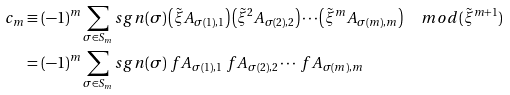Convert formula to latex. <formula><loc_0><loc_0><loc_500><loc_500>c _ { m } & \equiv ( - 1 ) ^ { m } \sum _ { \sigma \in S _ { m } } s g n ( \sigma ) \left ( \tilde { \xi } A _ { \sigma ( 1 ) , 1 } \right ) \left ( \tilde { \xi } ^ { 2 } A _ { \sigma ( 2 ) , 2 } \right ) \cdots \left ( \tilde { \xi } ^ { m } A _ { \sigma ( m ) , m } \right ) \quad m o d ( \tilde { \xi } ^ { m + 1 } ) \\ & = ( - 1 ) ^ { m } \sum _ { \sigma \in S _ { m } } s g n ( \sigma ) \ f A _ { \sigma ( 1 ) , 1 } \ f A _ { \sigma ( 2 ) , 2 } \cdots \ f A _ { \sigma ( m ) , m }</formula> 